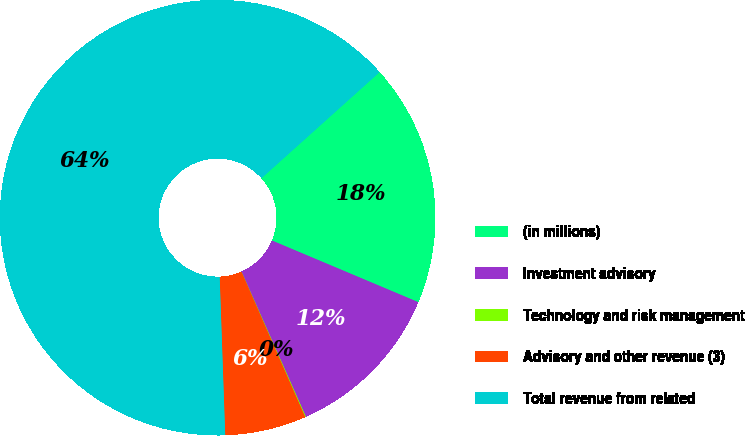<chart> <loc_0><loc_0><loc_500><loc_500><pie_chart><fcel>(in millions)<fcel>Investment advisory<fcel>Technology and risk management<fcel>Advisory and other revenue (3)<fcel>Total revenue from related<nl><fcel>17.99%<fcel>12.01%<fcel>0.06%<fcel>6.03%<fcel>63.91%<nl></chart> 